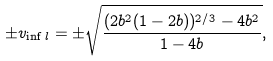Convert formula to latex. <formula><loc_0><loc_0><loc_500><loc_500>\pm v _ { \inf l } = \pm \sqrt { \frac { ( 2 b ^ { 2 } ( 1 - 2 b ) ) ^ { 2 / 3 } - 4 b ^ { 2 } } { 1 - 4 b } } ,</formula> 